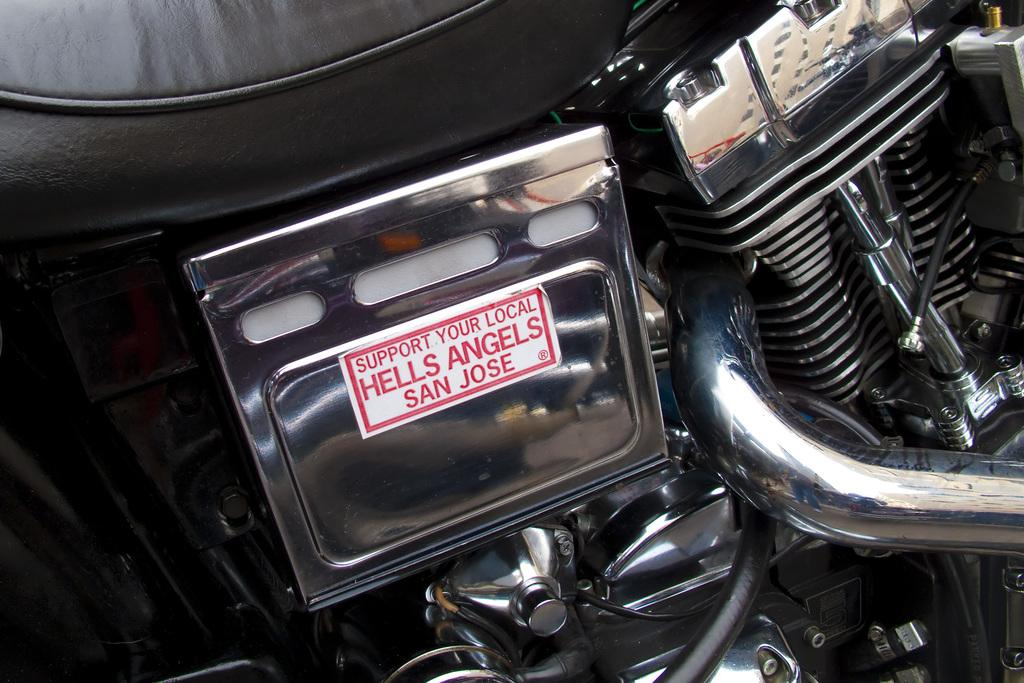What type of vehicle is depicted in the image? The image features visible in the image are parts of a motorcycle. Can you describe any specific parts of the motorcycle that can be seen? Unfortunately, the provided facts do not specify any particular parts of the motorcycle that are visible in the image. What type of sugar is being sold at the market in the image? There is no market or sugar present in the image; it only features parts of a motorcycle. 